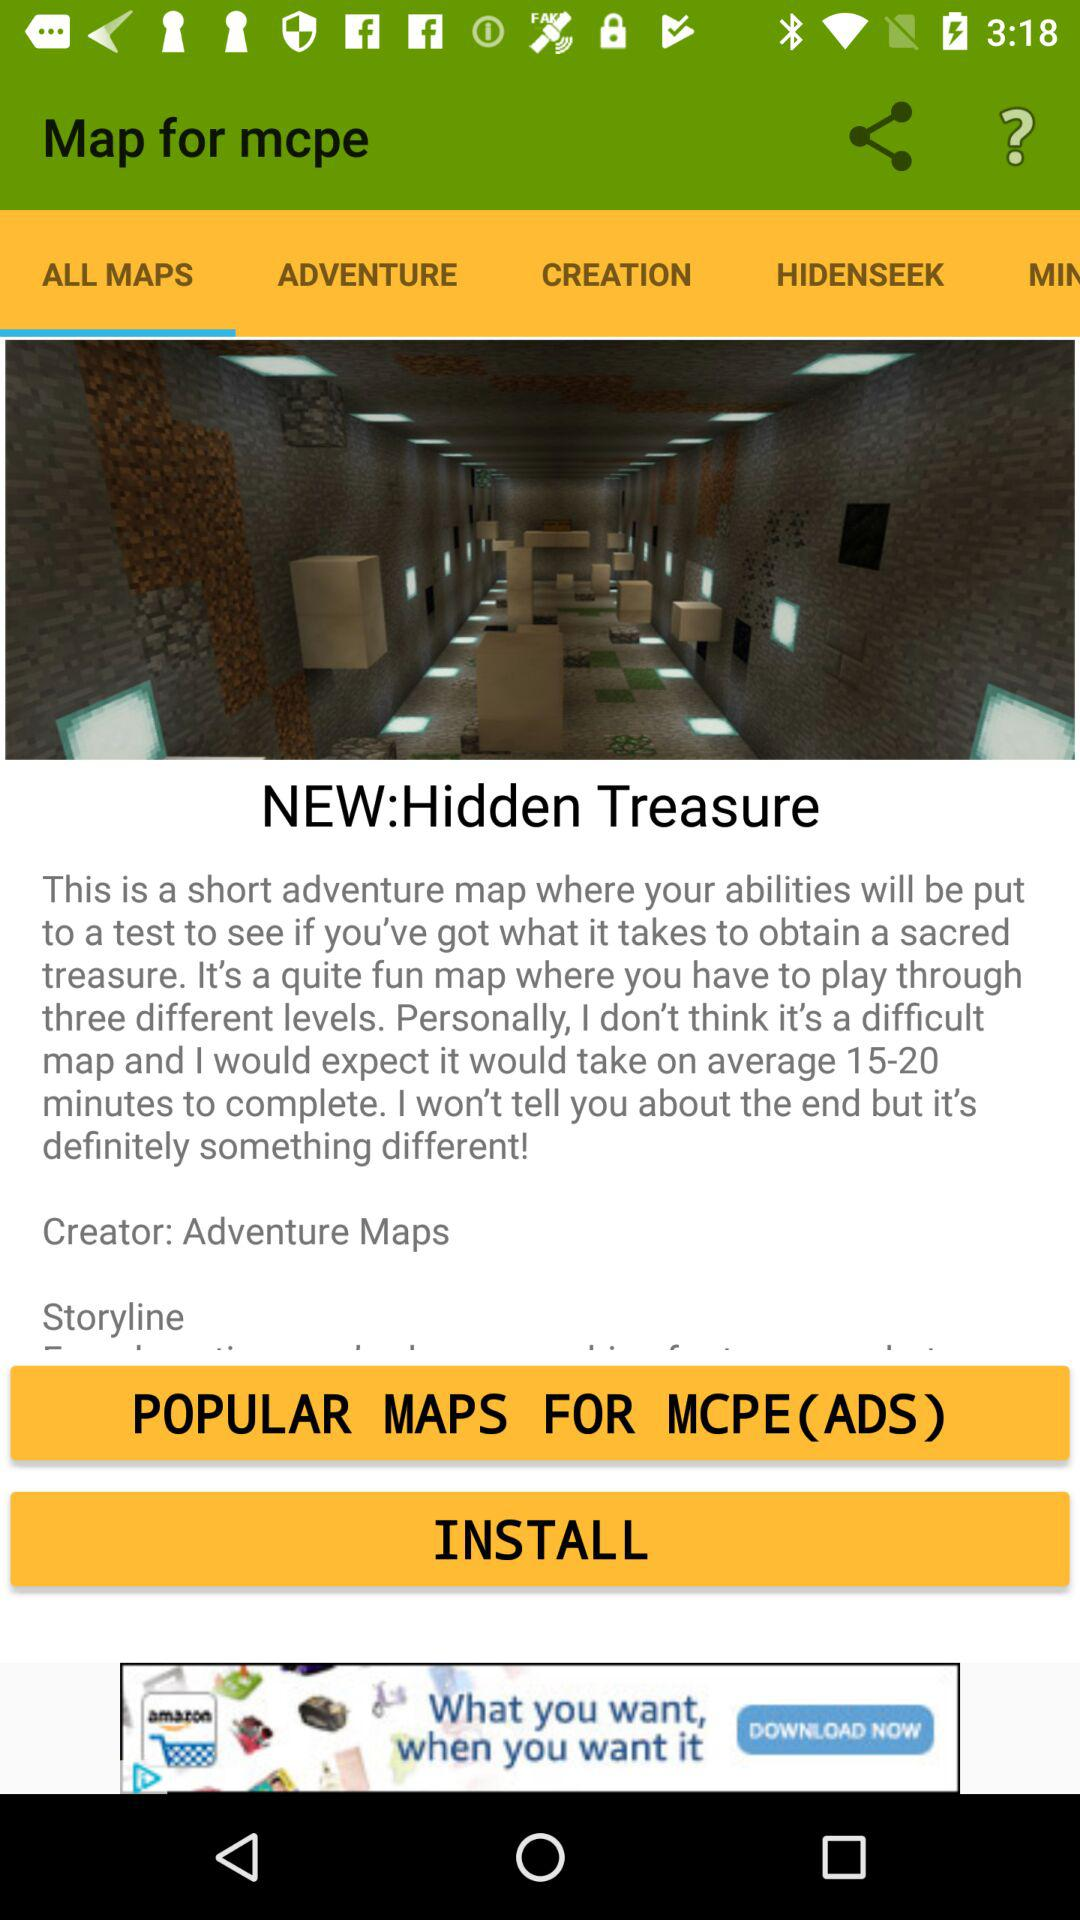How many levels does the map have?
Answer the question using a single word or phrase. 3 